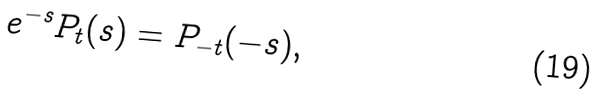Convert formula to latex. <formula><loc_0><loc_0><loc_500><loc_500>e ^ { - s } P _ { t } ( s ) = P _ { - t } ( - s ) ,</formula> 